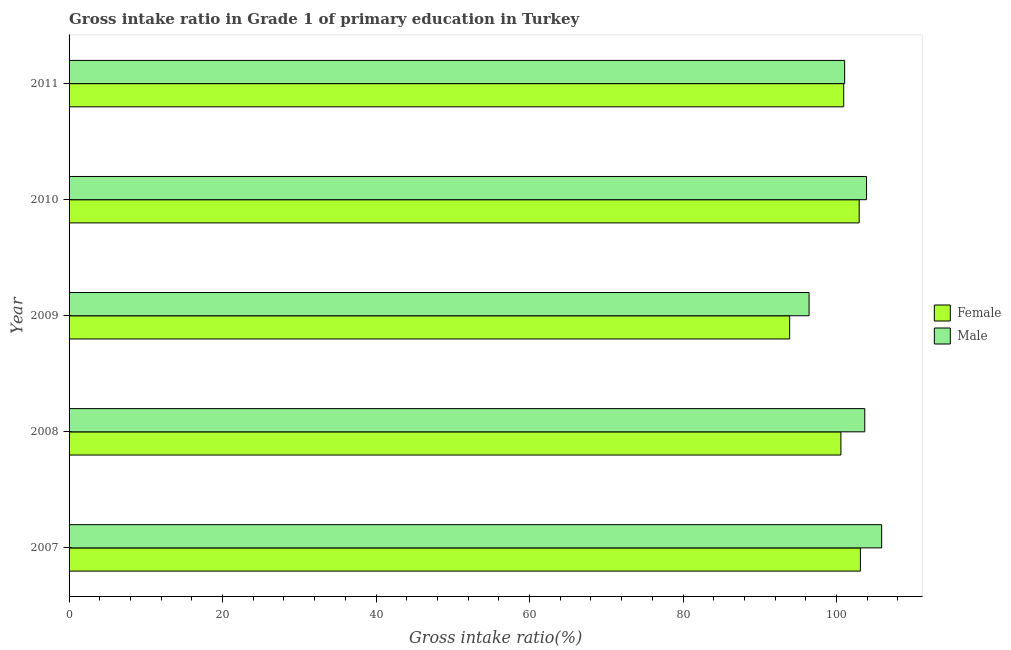How many bars are there on the 1st tick from the top?
Offer a very short reply. 2. How many bars are there on the 3rd tick from the bottom?
Offer a terse response. 2. What is the gross intake ratio(female) in 2011?
Provide a short and direct response. 100.93. Across all years, what is the maximum gross intake ratio(female)?
Your answer should be very brief. 103.11. Across all years, what is the minimum gross intake ratio(female)?
Make the answer very short. 93.89. In which year was the gross intake ratio(female) maximum?
Provide a succinct answer. 2007. What is the total gross intake ratio(male) in the graph?
Ensure brevity in your answer.  510.94. What is the difference between the gross intake ratio(female) in 2007 and that in 2011?
Ensure brevity in your answer.  2.17. What is the difference between the gross intake ratio(female) in 2010 and the gross intake ratio(male) in 2008?
Your answer should be compact. -0.73. What is the average gross intake ratio(female) per year?
Your response must be concise. 100.29. In the year 2007, what is the difference between the gross intake ratio(female) and gross intake ratio(male)?
Provide a short and direct response. -2.77. In how many years, is the gross intake ratio(male) greater than 104 %?
Your answer should be very brief. 1. Is the gross intake ratio(male) in 2007 less than that in 2010?
Keep it short and to the point. No. What is the difference between the highest and the second highest gross intake ratio(male)?
Make the answer very short. 1.97. What is the difference between the highest and the lowest gross intake ratio(female)?
Your answer should be compact. 9.22. Is the sum of the gross intake ratio(female) in 2008 and 2009 greater than the maximum gross intake ratio(male) across all years?
Give a very brief answer. Yes. What does the 2nd bar from the top in 2010 represents?
Offer a very short reply. Female. What does the 2nd bar from the bottom in 2007 represents?
Make the answer very short. Male. How many bars are there?
Your response must be concise. 10. How many years are there in the graph?
Offer a very short reply. 5. Are the values on the major ticks of X-axis written in scientific E-notation?
Your response must be concise. No. Where does the legend appear in the graph?
Ensure brevity in your answer.  Center right. How are the legend labels stacked?
Offer a terse response. Vertical. What is the title of the graph?
Give a very brief answer. Gross intake ratio in Grade 1 of primary education in Turkey. What is the label or title of the X-axis?
Offer a terse response. Gross intake ratio(%). What is the Gross intake ratio(%) of Female in 2007?
Your answer should be very brief. 103.11. What is the Gross intake ratio(%) of Male in 2007?
Make the answer very short. 105.88. What is the Gross intake ratio(%) in Female in 2008?
Keep it short and to the point. 100.57. What is the Gross intake ratio(%) in Male in 2008?
Offer a terse response. 103.68. What is the Gross intake ratio(%) in Female in 2009?
Make the answer very short. 93.89. What is the Gross intake ratio(%) in Male in 2009?
Give a very brief answer. 96.42. What is the Gross intake ratio(%) in Female in 2010?
Offer a terse response. 102.95. What is the Gross intake ratio(%) in Male in 2010?
Offer a terse response. 103.91. What is the Gross intake ratio(%) of Female in 2011?
Offer a terse response. 100.93. What is the Gross intake ratio(%) of Male in 2011?
Ensure brevity in your answer.  101.06. Across all years, what is the maximum Gross intake ratio(%) in Female?
Your answer should be compact. 103.11. Across all years, what is the maximum Gross intake ratio(%) of Male?
Your answer should be very brief. 105.88. Across all years, what is the minimum Gross intake ratio(%) in Female?
Provide a short and direct response. 93.89. Across all years, what is the minimum Gross intake ratio(%) in Male?
Offer a terse response. 96.42. What is the total Gross intake ratio(%) of Female in the graph?
Ensure brevity in your answer.  501.45. What is the total Gross intake ratio(%) of Male in the graph?
Your answer should be compact. 510.94. What is the difference between the Gross intake ratio(%) of Female in 2007 and that in 2008?
Keep it short and to the point. 2.54. What is the difference between the Gross intake ratio(%) in Male in 2007 and that in 2008?
Give a very brief answer. 2.2. What is the difference between the Gross intake ratio(%) in Female in 2007 and that in 2009?
Ensure brevity in your answer.  9.22. What is the difference between the Gross intake ratio(%) of Male in 2007 and that in 2009?
Give a very brief answer. 9.46. What is the difference between the Gross intake ratio(%) in Female in 2007 and that in 2010?
Your response must be concise. 0.16. What is the difference between the Gross intake ratio(%) in Male in 2007 and that in 2010?
Provide a short and direct response. 1.97. What is the difference between the Gross intake ratio(%) in Female in 2007 and that in 2011?
Provide a short and direct response. 2.17. What is the difference between the Gross intake ratio(%) of Male in 2007 and that in 2011?
Ensure brevity in your answer.  4.82. What is the difference between the Gross intake ratio(%) of Female in 2008 and that in 2009?
Your response must be concise. 6.68. What is the difference between the Gross intake ratio(%) in Male in 2008 and that in 2009?
Your answer should be compact. 7.26. What is the difference between the Gross intake ratio(%) in Female in 2008 and that in 2010?
Keep it short and to the point. -2.38. What is the difference between the Gross intake ratio(%) of Male in 2008 and that in 2010?
Offer a terse response. -0.23. What is the difference between the Gross intake ratio(%) in Female in 2008 and that in 2011?
Your answer should be compact. -0.37. What is the difference between the Gross intake ratio(%) of Male in 2008 and that in 2011?
Give a very brief answer. 2.62. What is the difference between the Gross intake ratio(%) in Female in 2009 and that in 2010?
Keep it short and to the point. -9.06. What is the difference between the Gross intake ratio(%) of Male in 2009 and that in 2010?
Provide a succinct answer. -7.49. What is the difference between the Gross intake ratio(%) of Female in 2009 and that in 2011?
Keep it short and to the point. -7.04. What is the difference between the Gross intake ratio(%) in Male in 2009 and that in 2011?
Ensure brevity in your answer.  -4.64. What is the difference between the Gross intake ratio(%) in Female in 2010 and that in 2011?
Give a very brief answer. 2.02. What is the difference between the Gross intake ratio(%) of Male in 2010 and that in 2011?
Provide a succinct answer. 2.85. What is the difference between the Gross intake ratio(%) of Female in 2007 and the Gross intake ratio(%) of Male in 2008?
Your answer should be very brief. -0.57. What is the difference between the Gross intake ratio(%) of Female in 2007 and the Gross intake ratio(%) of Male in 2009?
Provide a short and direct response. 6.69. What is the difference between the Gross intake ratio(%) of Female in 2007 and the Gross intake ratio(%) of Male in 2010?
Keep it short and to the point. -0.8. What is the difference between the Gross intake ratio(%) in Female in 2007 and the Gross intake ratio(%) in Male in 2011?
Give a very brief answer. 2.05. What is the difference between the Gross intake ratio(%) in Female in 2008 and the Gross intake ratio(%) in Male in 2009?
Provide a short and direct response. 4.15. What is the difference between the Gross intake ratio(%) of Female in 2008 and the Gross intake ratio(%) of Male in 2010?
Give a very brief answer. -3.34. What is the difference between the Gross intake ratio(%) in Female in 2008 and the Gross intake ratio(%) in Male in 2011?
Provide a short and direct response. -0.49. What is the difference between the Gross intake ratio(%) of Female in 2009 and the Gross intake ratio(%) of Male in 2010?
Ensure brevity in your answer.  -10.02. What is the difference between the Gross intake ratio(%) of Female in 2009 and the Gross intake ratio(%) of Male in 2011?
Your response must be concise. -7.17. What is the difference between the Gross intake ratio(%) in Female in 2010 and the Gross intake ratio(%) in Male in 2011?
Your response must be concise. 1.89. What is the average Gross intake ratio(%) of Female per year?
Your answer should be very brief. 100.29. What is the average Gross intake ratio(%) in Male per year?
Keep it short and to the point. 102.19. In the year 2007, what is the difference between the Gross intake ratio(%) of Female and Gross intake ratio(%) of Male?
Keep it short and to the point. -2.77. In the year 2008, what is the difference between the Gross intake ratio(%) in Female and Gross intake ratio(%) in Male?
Provide a succinct answer. -3.11. In the year 2009, what is the difference between the Gross intake ratio(%) in Female and Gross intake ratio(%) in Male?
Offer a very short reply. -2.53. In the year 2010, what is the difference between the Gross intake ratio(%) in Female and Gross intake ratio(%) in Male?
Your answer should be compact. -0.96. In the year 2011, what is the difference between the Gross intake ratio(%) in Female and Gross intake ratio(%) in Male?
Keep it short and to the point. -0.12. What is the ratio of the Gross intake ratio(%) in Female in 2007 to that in 2008?
Give a very brief answer. 1.03. What is the ratio of the Gross intake ratio(%) in Male in 2007 to that in 2008?
Ensure brevity in your answer.  1.02. What is the ratio of the Gross intake ratio(%) of Female in 2007 to that in 2009?
Make the answer very short. 1.1. What is the ratio of the Gross intake ratio(%) of Male in 2007 to that in 2009?
Make the answer very short. 1.1. What is the ratio of the Gross intake ratio(%) of Female in 2007 to that in 2010?
Your answer should be very brief. 1. What is the ratio of the Gross intake ratio(%) in Male in 2007 to that in 2010?
Your response must be concise. 1.02. What is the ratio of the Gross intake ratio(%) of Female in 2007 to that in 2011?
Your answer should be compact. 1.02. What is the ratio of the Gross intake ratio(%) of Male in 2007 to that in 2011?
Offer a very short reply. 1.05. What is the ratio of the Gross intake ratio(%) of Female in 2008 to that in 2009?
Provide a succinct answer. 1.07. What is the ratio of the Gross intake ratio(%) of Male in 2008 to that in 2009?
Offer a very short reply. 1.08. What is the ratio of the Gross intake ratio(%) of Female in 2008 to that in 2010?
Ensure brevity in your answer.  0.98. What is the ratio of the Gross intake ratio(%) of Male in 2008 to that in 2010?
Give a very brief answer. 1. What is the ratio of the Gross intake ratio(%) of Male in 2008 to that in 2011?
Keep it short and to the point. 1.03. What is the ratio of the Gross intake ratio(%) of Female in 2009 to that in 2010?
Give a very brief answer. 0.91. What is the ratio of the Gross intake ratio(%) of Male in 2009 to that in 2010?
Ensure brevity in your answer.  0.93. What is the ratio of the Gross intake ratio(%) of Female in 2009 to that in 2011?
Provide a succinct answer. 0.93. What is the ratio of the Gross intake ratio(%) in Male in 2009 to that in 2011?
Your answer should be compact. 0.95. What is the ratio of the Gross intake ratio(%) of Female in 2010 to that in 2011?
Provide a short and direct response. 1.02. What is the ratio of the Gross intake ratio(%) of Male in 2010 to that in 2011?
Offer a terse response. 1.03. What is the difference between the highest and the second highest Gross intake ratio(%) of Female?
Provide a succinct answer. 0.16. What is the difference between the highest and the second highest Gross intake ratio(%) in Male?
Your answer should be compact. 1.97. What is the difference between the highest and the lowest Gross intake ratio(%) in Female?
Your answer should be compact. 9.22. What is the difference between the highest and the lowest Gross intake ratio(%) of Male?
Ensure brevity in your answer.  9.46. 